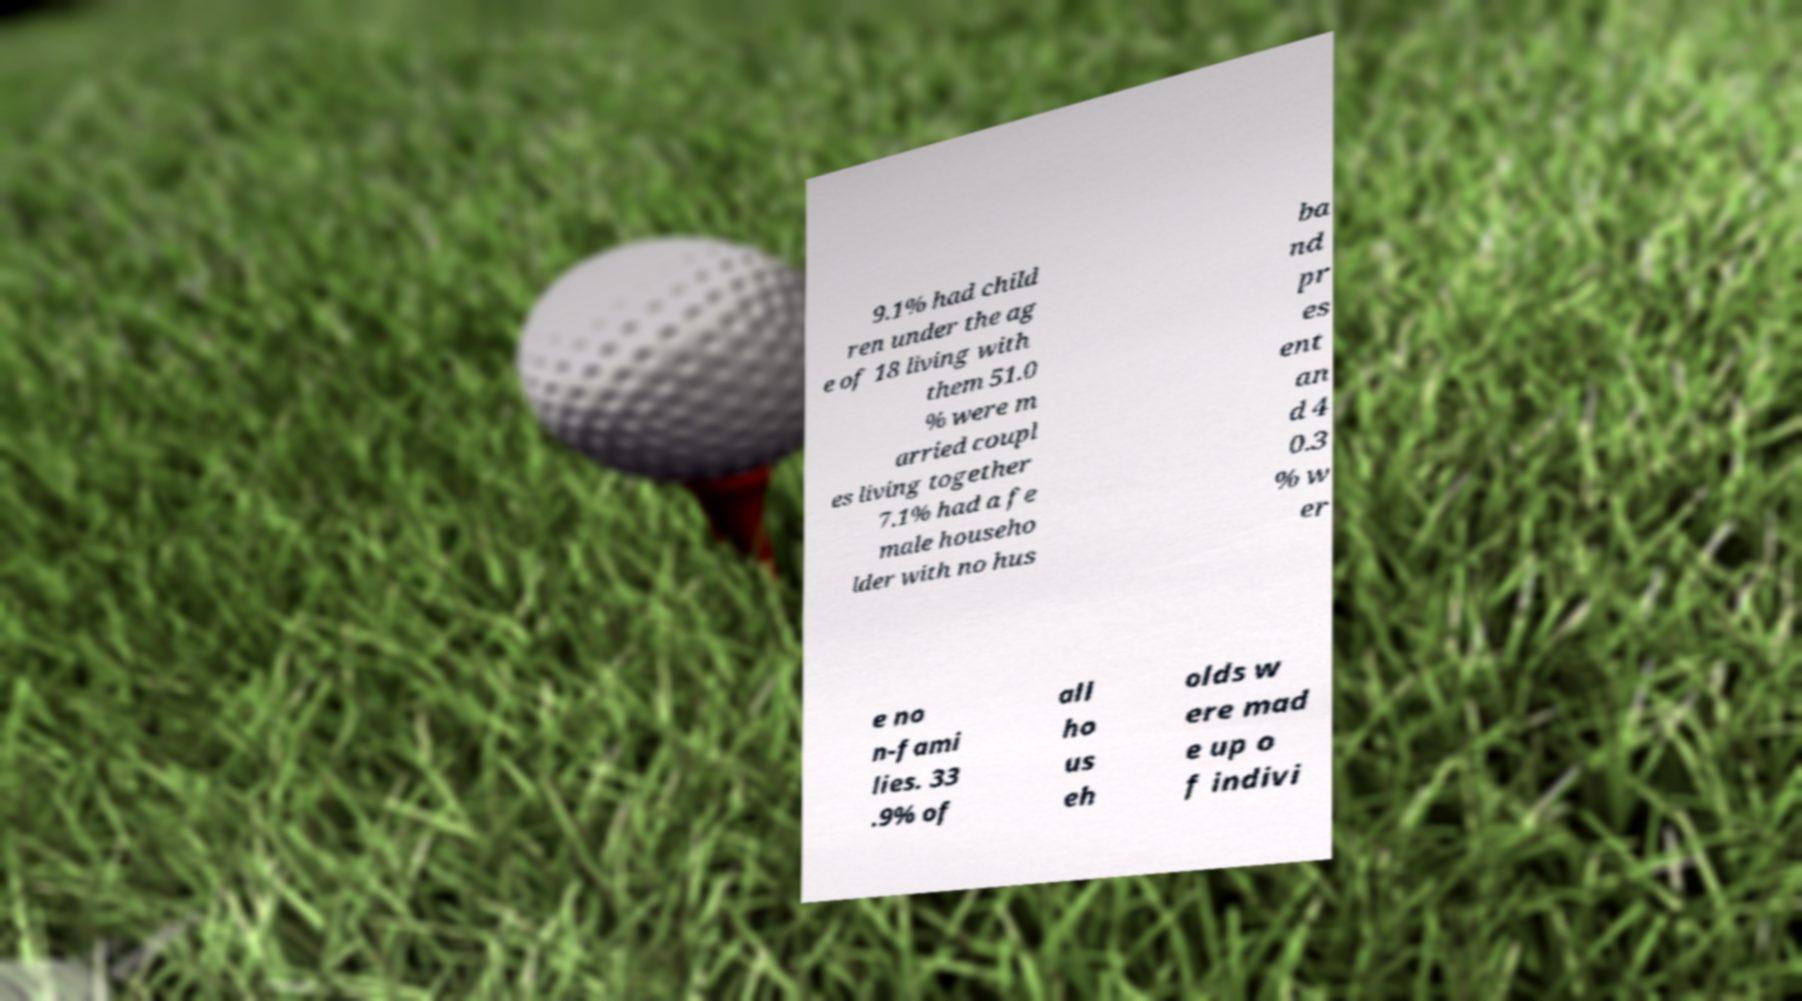There's text embedded in this image that I need extracted. Can you transcribe it verbatim? 9.1% had child ren under the ag e of 18 living with them 51.0 % were m arried coupl es living together 7.1% had a fe male househo lder with no hus ba nd pr es ent an d 4 0.3 % w er e no n-fami lies. 33 .9% of all ho us eh olds w ere mad e up o f indivi 